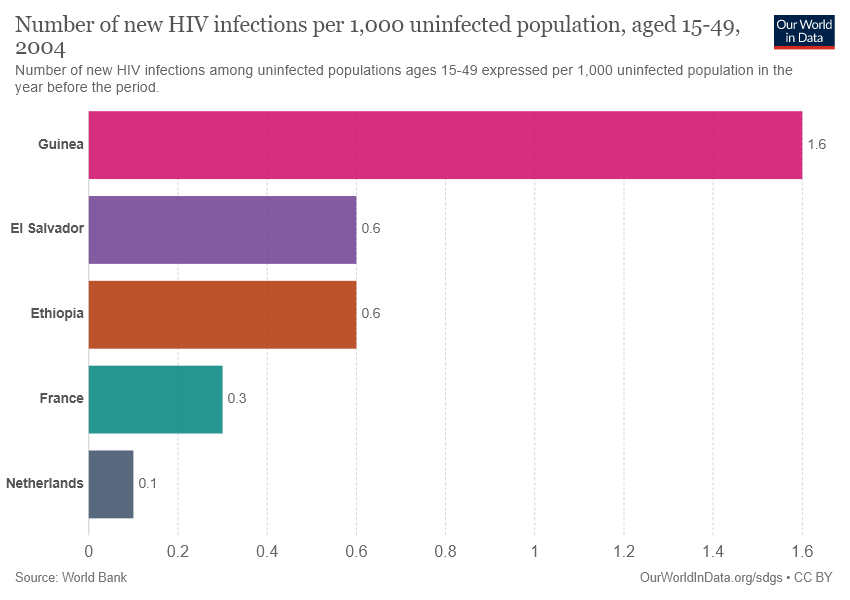Draw attention to some important aspects in this diagram. If the Netherlands' team represents a certain color, it is likely to be dark blue. France and Ethiopia are different in terms of their GDP per capita, with France having a higher value of 0.3 times the per capita GDP of Ethiopia. 